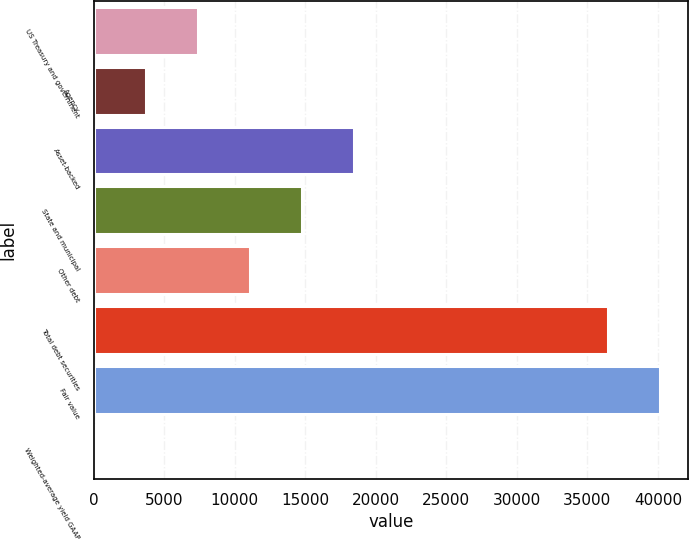<chart> <loc_0><loc_0><loc_500><loc_500><bar_chart><fcel>US Treasury and government<fcel>Agency<fcel>Asset-backed<fcel>State and municipal<fcel>Other debt<fcel>Total debt securities<fcel>Fair value<fcel>Weighted-average yield GAAP<nl><fcel>7376.72<fcel>3689.94<fcel>18437.1<fcel>14750.3<fcel>11063.5<fcel>36463<fcel>40149.8<fcel>3.16<nl></chart> 